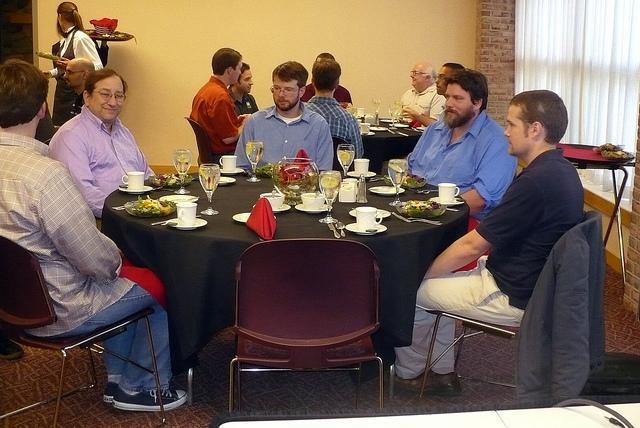How many men are at the table?
Give a very brief answer. 5. How many people are in the image?
Give a very brief answer. 12. How many chairs are in the picture?
Give a very brief answer. 3. How many people are there?
Give a very brief answer. 8. How many bananas are there?
Give a very brief answer. 0. 